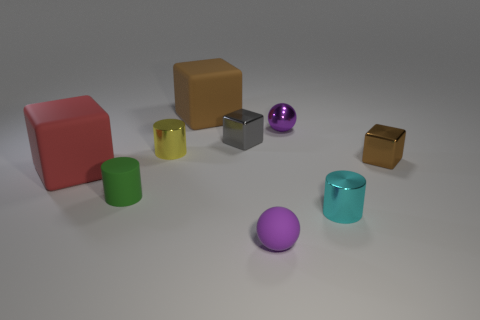Subtract 1 blocks. How many blocks are left? 3 Add 1 small cyan cylinders. How many objects exist? 10 Subtract all spheres. How many objects are left? 7 Subtract all brown matte balls. Subtract all brown metallic things. How many objects are left? 8 Add 9 big red matte blocks. How many big red matte blocks are left? 10 Add 1 small things. How many small things exist? 8 Subtract 0 blue balls. How many objects are left? 9 